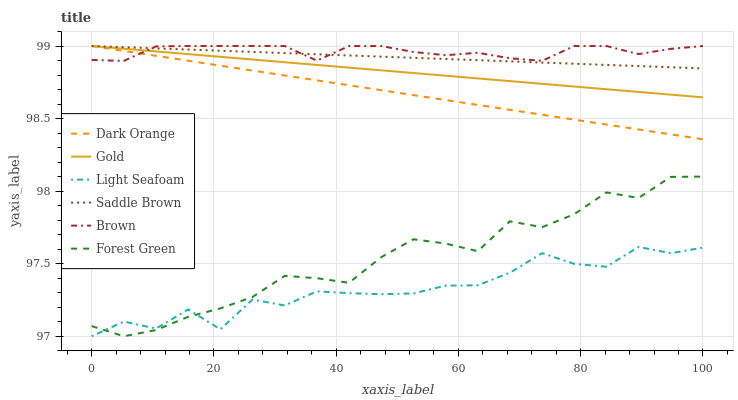Does Gold have the minimum area under the curve?
Answer yes or no. No. Does Gold have the maximum area under the curve?
Answer yes or no. No. Is Gold the smoothest?
Answer yes or no. No. Is Gold the roughest?
Answer yes or no. No. Does Gold have the lowest value?
Answer yes or no. No. Does Forest Green have the highest value?
Answer yes or no. No. Is Forest Green less than Saddle Brown?
Answer yes or no. Yes. Is Gold greater than Light Seafoam?
Answer yes or no. Yes. Does Forest Green intersect Saddle Brown?
Answer yes or no. No. 